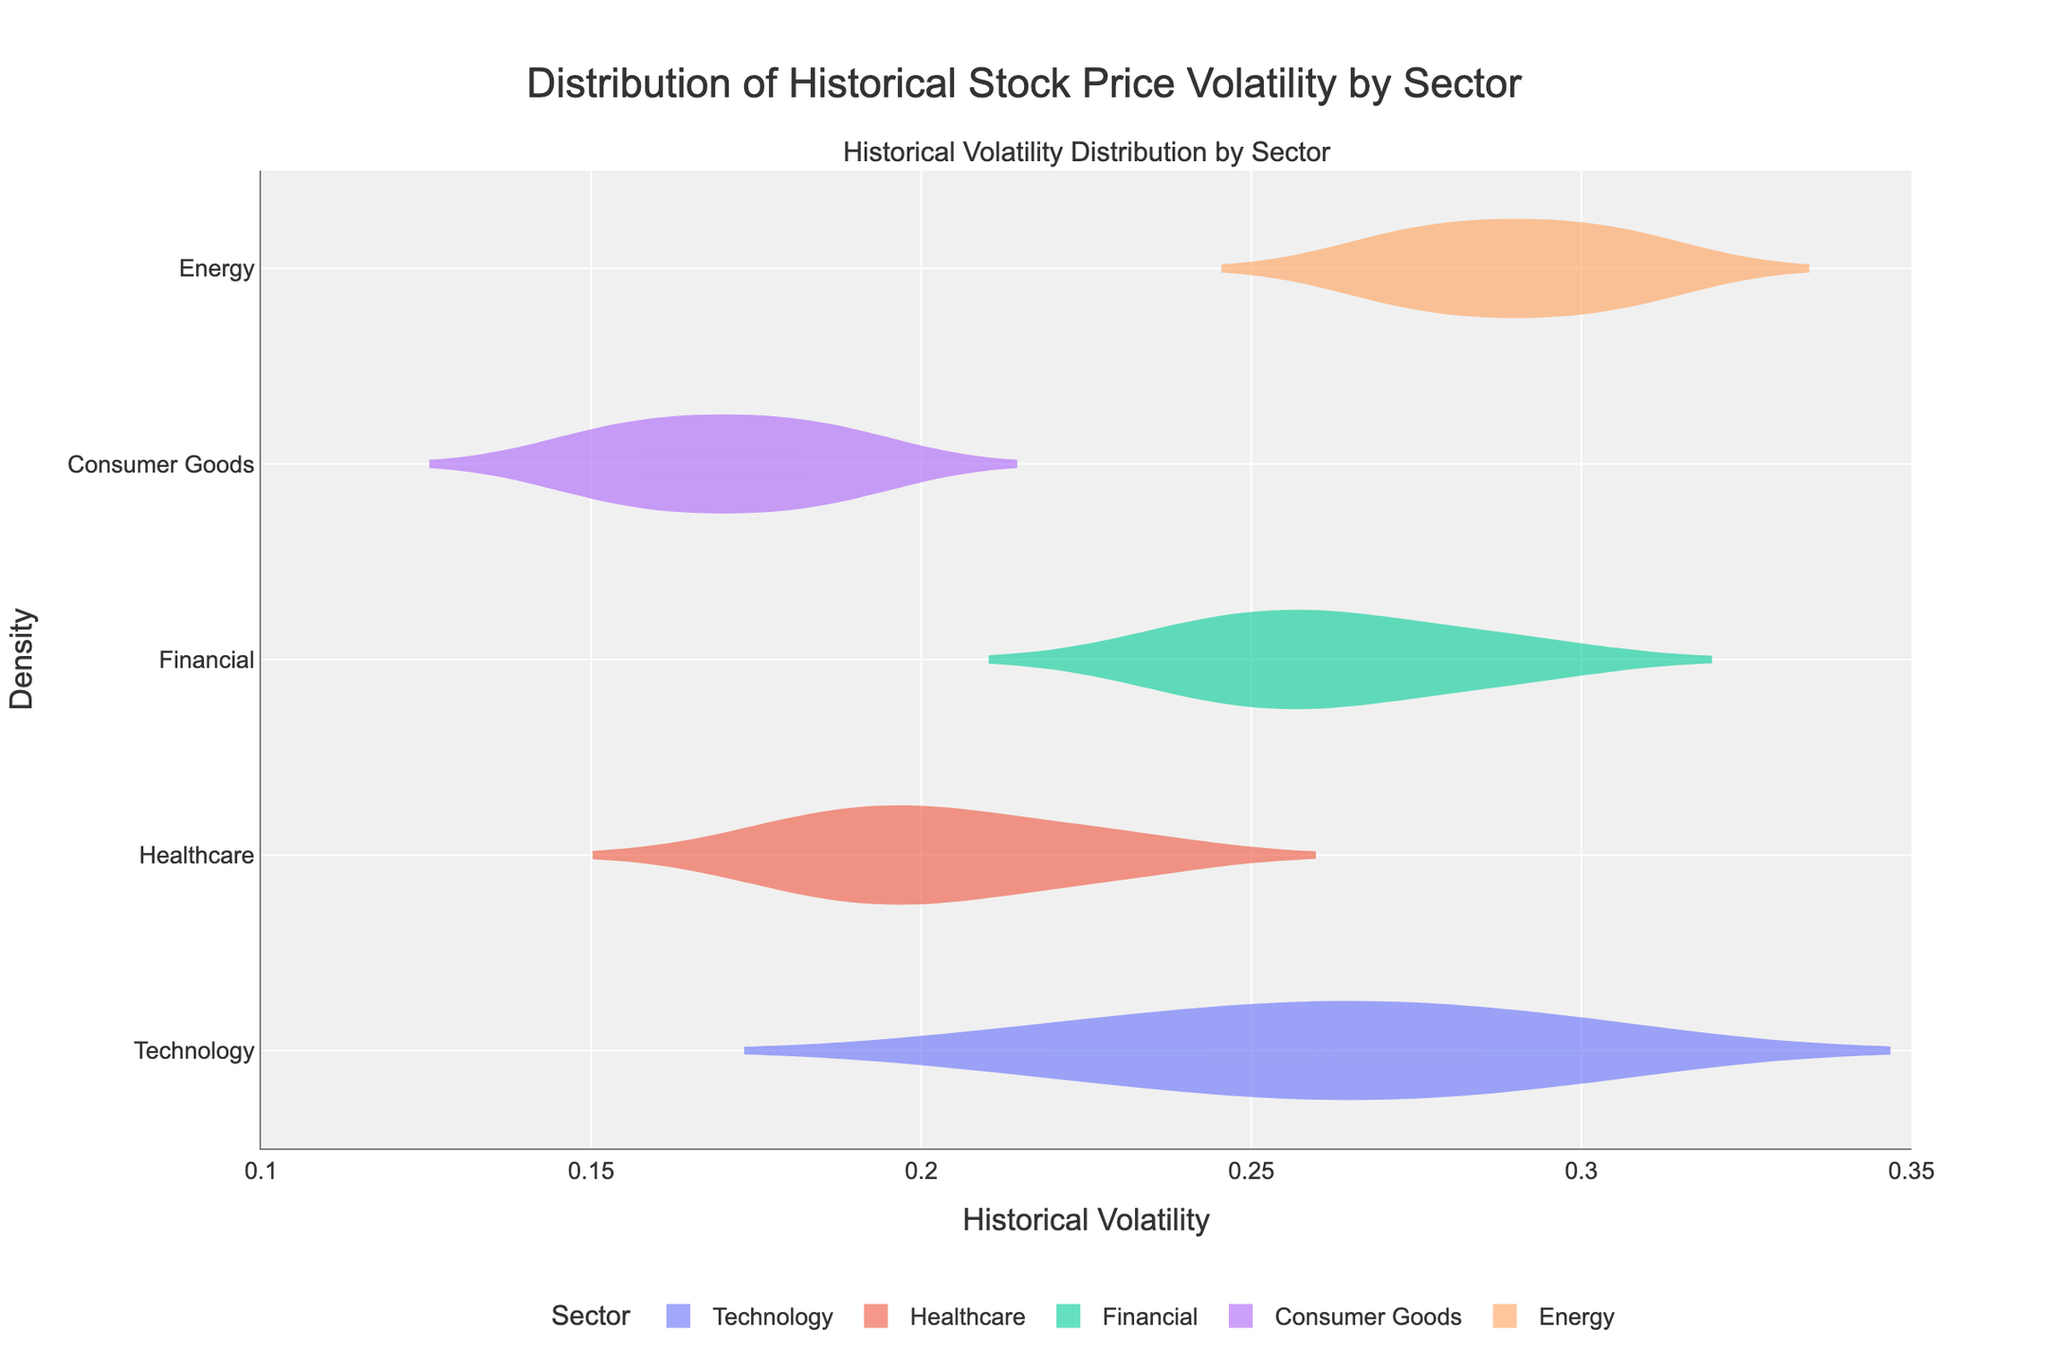What is the title of the plot? The title is written at the top of the chart and explains what the visual representation is about.
Answer: Distribution of Historical Stock Price Volatility by Sector Which sector shows the highest historical volatility? By looking at the vioplot distributions and their maximum values on the x-axis, we can identify which sector has the highest value.
Answer: Energy Which sector shows the lowest historical volatility? By comparing the lowest values of the violin plots, we can see which sector has the minimum historical volatility.
Answer: Consumer Goods How does the average historical volatility of the Technology sector compare to that of the Healthcare sector? To answer this, we look at the mean line within each violin plot for both sectors. The mean line for Technology is higher than that for Healthcare.
Answer: Technology has higher average volatility Which sector has the most stable stock prices, and how can you tell? Stability can be inferred from the narrowness and position of the violin plot. The Consumer Goods sector has the narrowest volatility range, indicating more stability.
Answer: Consumer Goods What is the typical historical volatility range for the Financial sector? Observing the Financial sector's violin plot, we can note the approximate range of its distribution.
Answer: ~0.24 to ~0.29 Is there any sector with significant overlap in their volatility distributions? By comparing the shapes and positions of the violin plots, we notice that the Financial and Energy sectors overlap significantly.
Answer: Yes, Financial and Energy Are there any sectors that have a mean volatility value less than 0.20? By checking the mean lines in each violin plot, the Healthcare and Consumer Goods sectors both have mean values less than 0.20.
Answer: Healthcare and Consumer Goods How does the range of historical volatility in the Energy sector compare to other sectors? The Energy sector has a wider range of historical volatility compared to others, which can be seen by the spread of the values in its violin plot.
Answer: Broader range Which sector appears to be the most volatile based on the distribution shape of their historical volatilities? By comparing the width and spread of each violin plot, the Energy sector has the widest and most spread-out distribution, indicating higher volatility.
Answer: Energy 